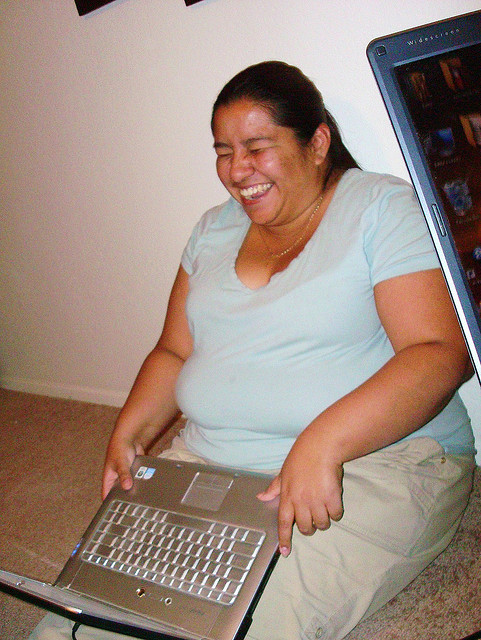<image>What brand of laptop is this? I am unsure of the brand of the laptop. It could be Dell, HP, Toshiba, or Apple. What brand of laptop is this? I don't know what brand of laptop this is. It can be Dell, HP, Toshiba or even Apple. 